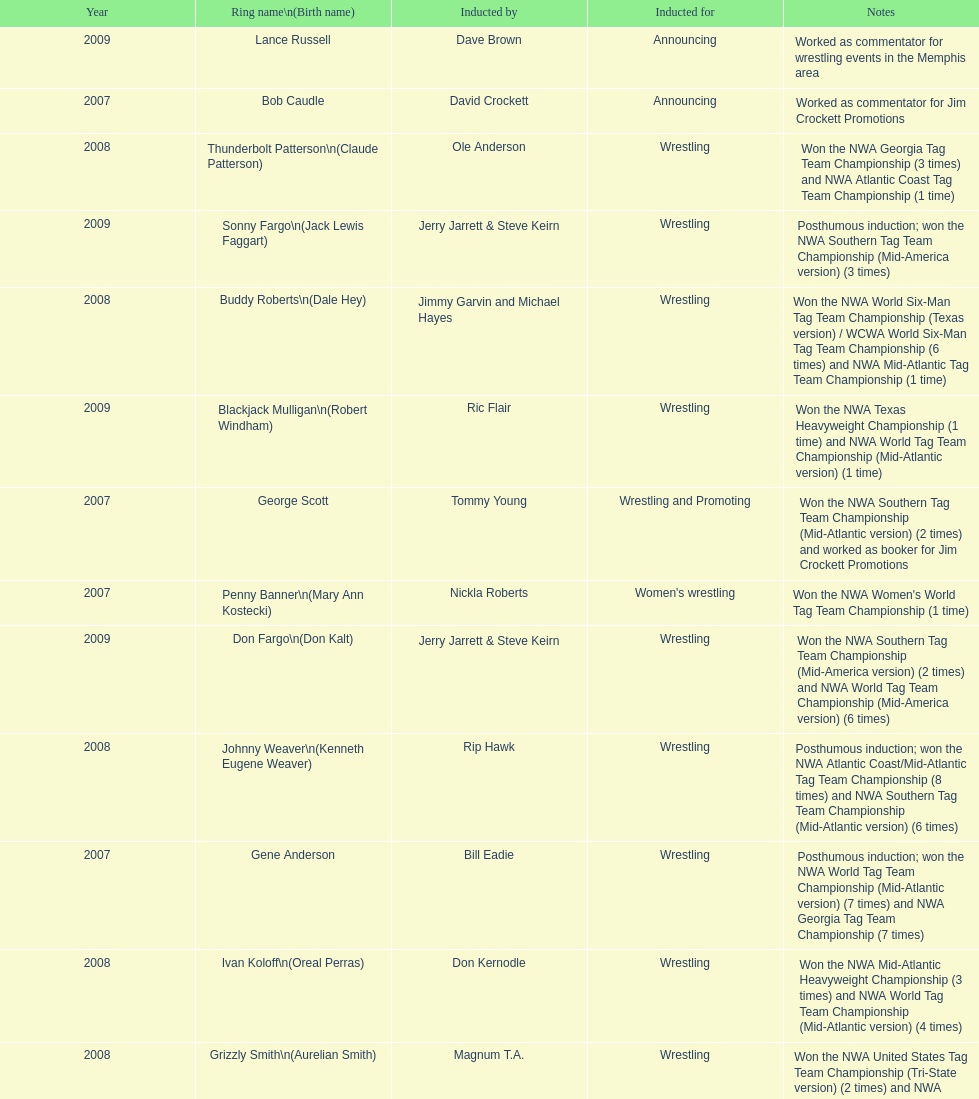How many members were inducted for announcing? 2. 